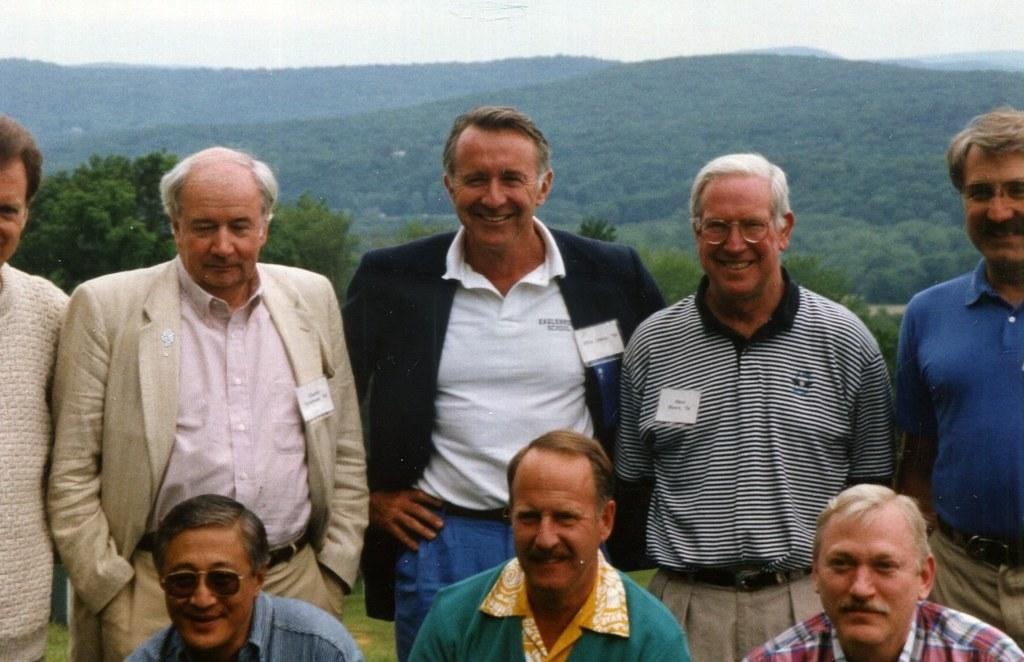What is the main subject of the image? The main subject of the image is a group of persons. What can be seen in the background of the image? There are trees and mountains in the background of the image. What is visible at the top of the image? The sky is visible at the top of the image. What type of pin is being used by the company in the image? There is no pin or company mentioned in the image; it features a group of persons with trees, mountains, and the sky in the background. What kind of beast is present in the image? There is no beast present in the image; it features a group of persons with trees, mountains, and the sky in the background. 